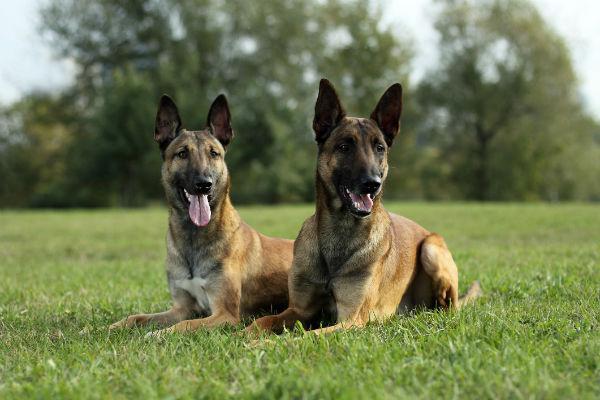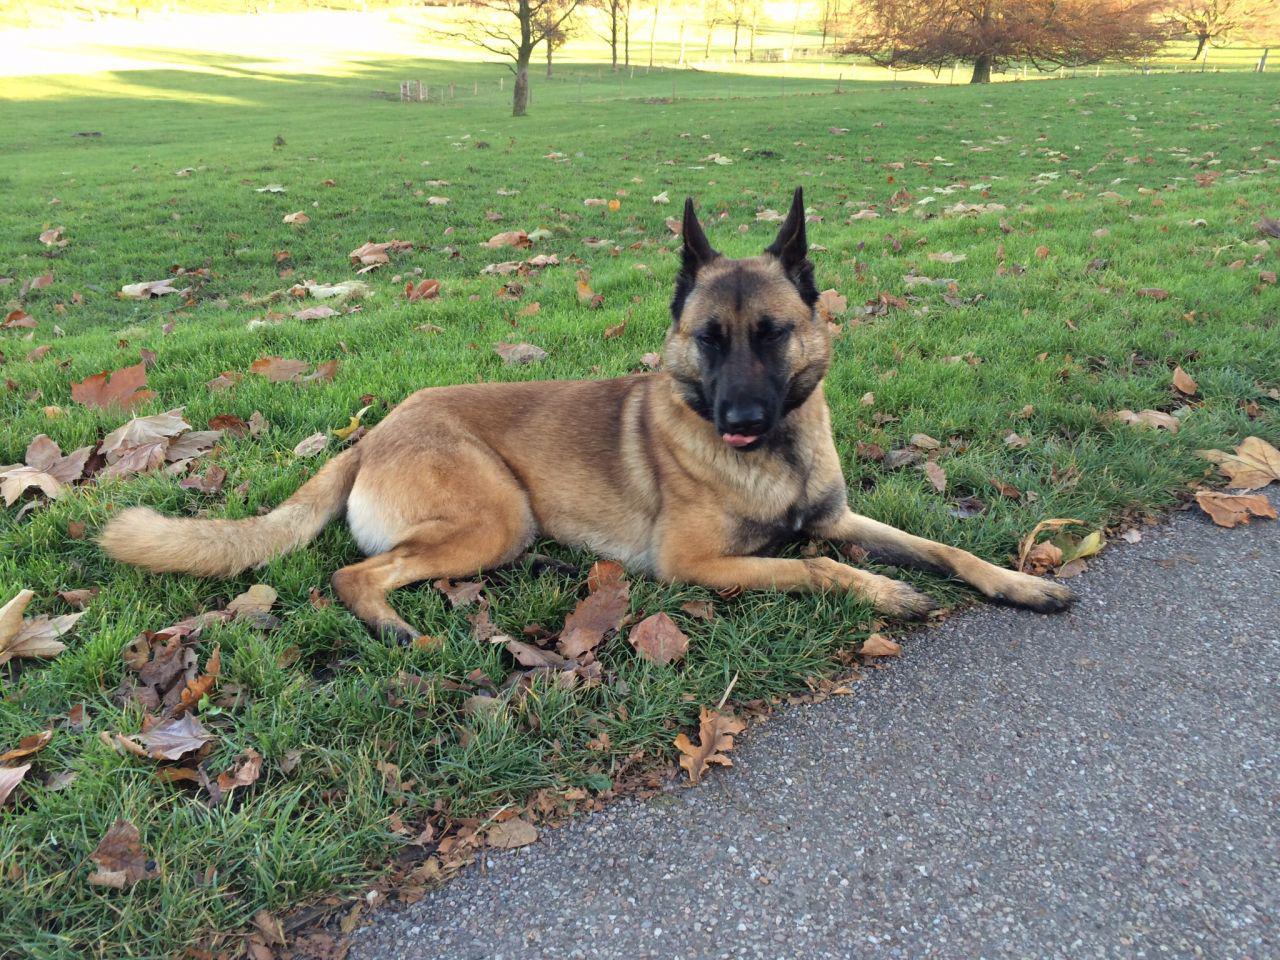The first image is the image on the left, the second image is the image on the right. Considering the images on both sides, is "There are three adult German Shepherds sitting in the grass." valid? Answer yes or no. Yes. 